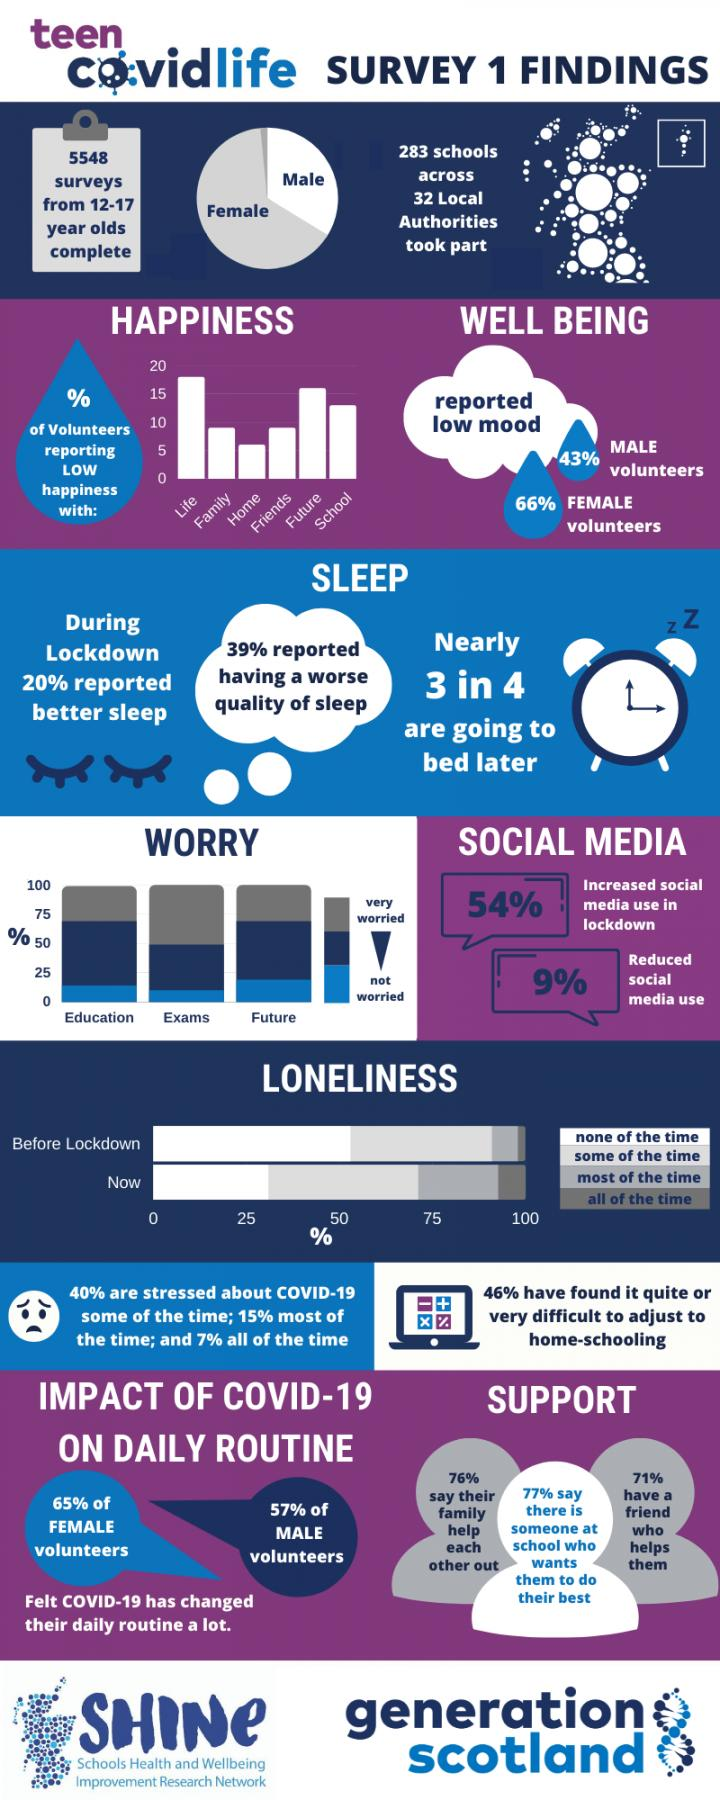Specify some key components in this picture. Seventy-one percent of respondents reported having a friend to support them. The majority of respondents, 62%, expressed concern about their exams, indicating that they were very worried about this aspect of their studies. During the lockdown, 9% of respondents reported a decrease in their usage of social media. According to the data, approximately 7% of respondents are constantly stressed about COVID-19. According to the survey, 76% of respondents had the support of their family to rely on. 